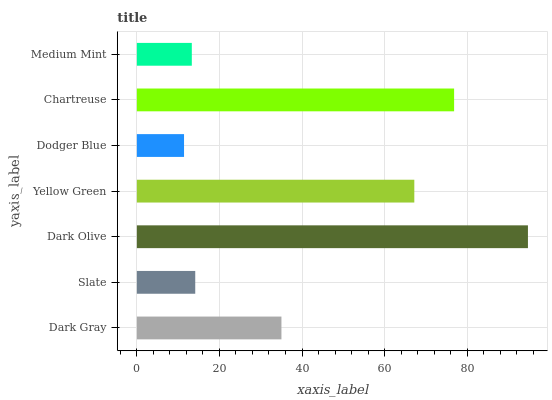Is Dodger Blue the minimum?
Answer yes or no. Yes. Is Dark Olive the maximum?
Answer yes or no. Yes. Is Slate the minimum?
Answer yes or no. No. Is Slate the maximum?
Answer yes or no. No. Is Dark Gray greater than Slate?
Answer yes or no. Yes. Is Slate less than Dark Gray?
Answer yes or no. Yes. Is Slate greater than Dark Gray?
Answer yes or no. No. Is Dark Gray less than Slate?
Answer yes or no. No. Is Dark Gray the high median?
Answer yes or no. Yes. Is Dark Gray the low median?
Answer yes or no. Yes. Is Dodger Blue the high median?
Answer yes or no. No. Is Chartreuse the low median?
Answer yes or no. No. 